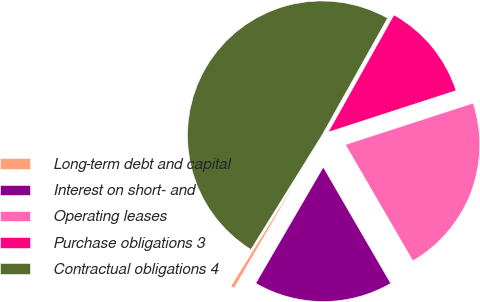Convert chart to OTSL. <chart><loc_0><loc_0><loc_500><loc_500><pie_chart><fcel>Long-term debt and capital<fcel>Interest on short- and<fcel>Operating leases<fcel>Purchase obligations 3<fcel>Contractual obligations 4<nl><fcel>0.47%<fcel>16.75%<fcel>21.63%<fcel>11.87%<fcel>49.27%<nl></chart> 